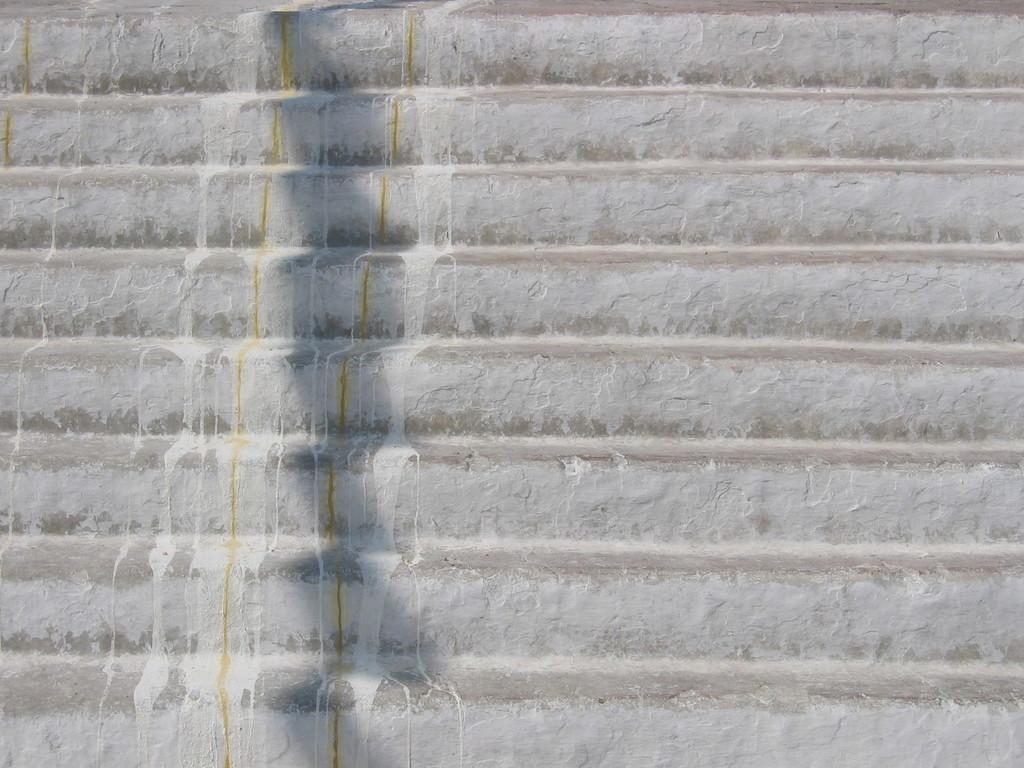Can you describe this image briefly? In this picture we can see a few stairs. 